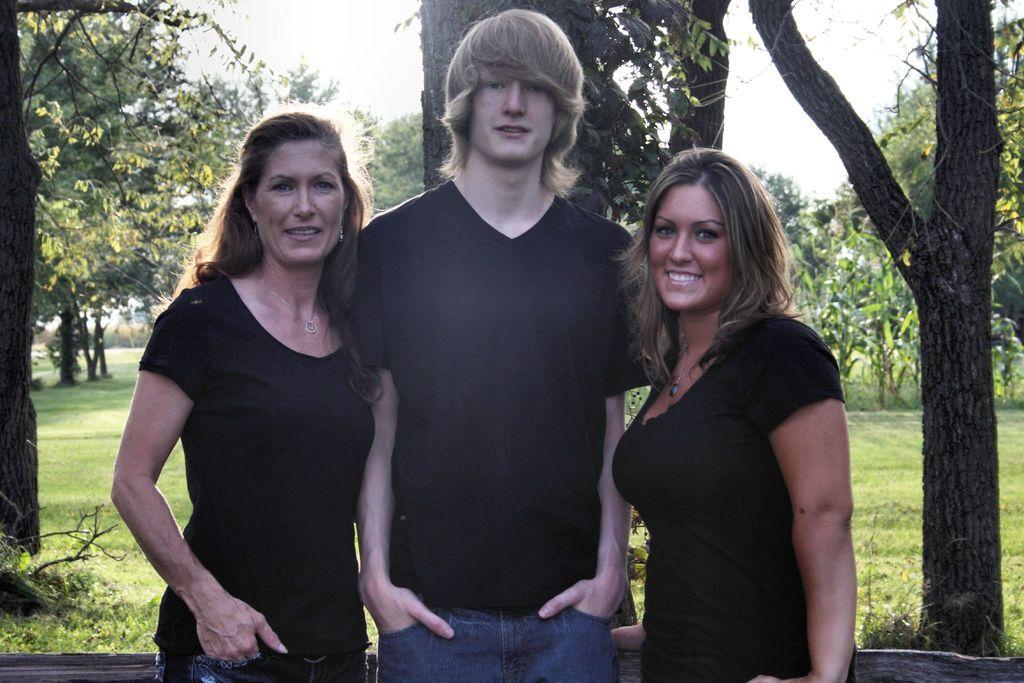How many people are in the image? There are three people in the image. What are the people doing in the image? The people are standing. What can be seen in the background of the image? There are trees and grass in the background of the image. What type of insurance policy do the trees in the background have? There is no information about insurance policies for the trees in the image, as they are not the focus of the image. 